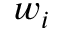<formula> <loc_0><loc_0><loc_500><loc_500>w _ { i }</formula> 